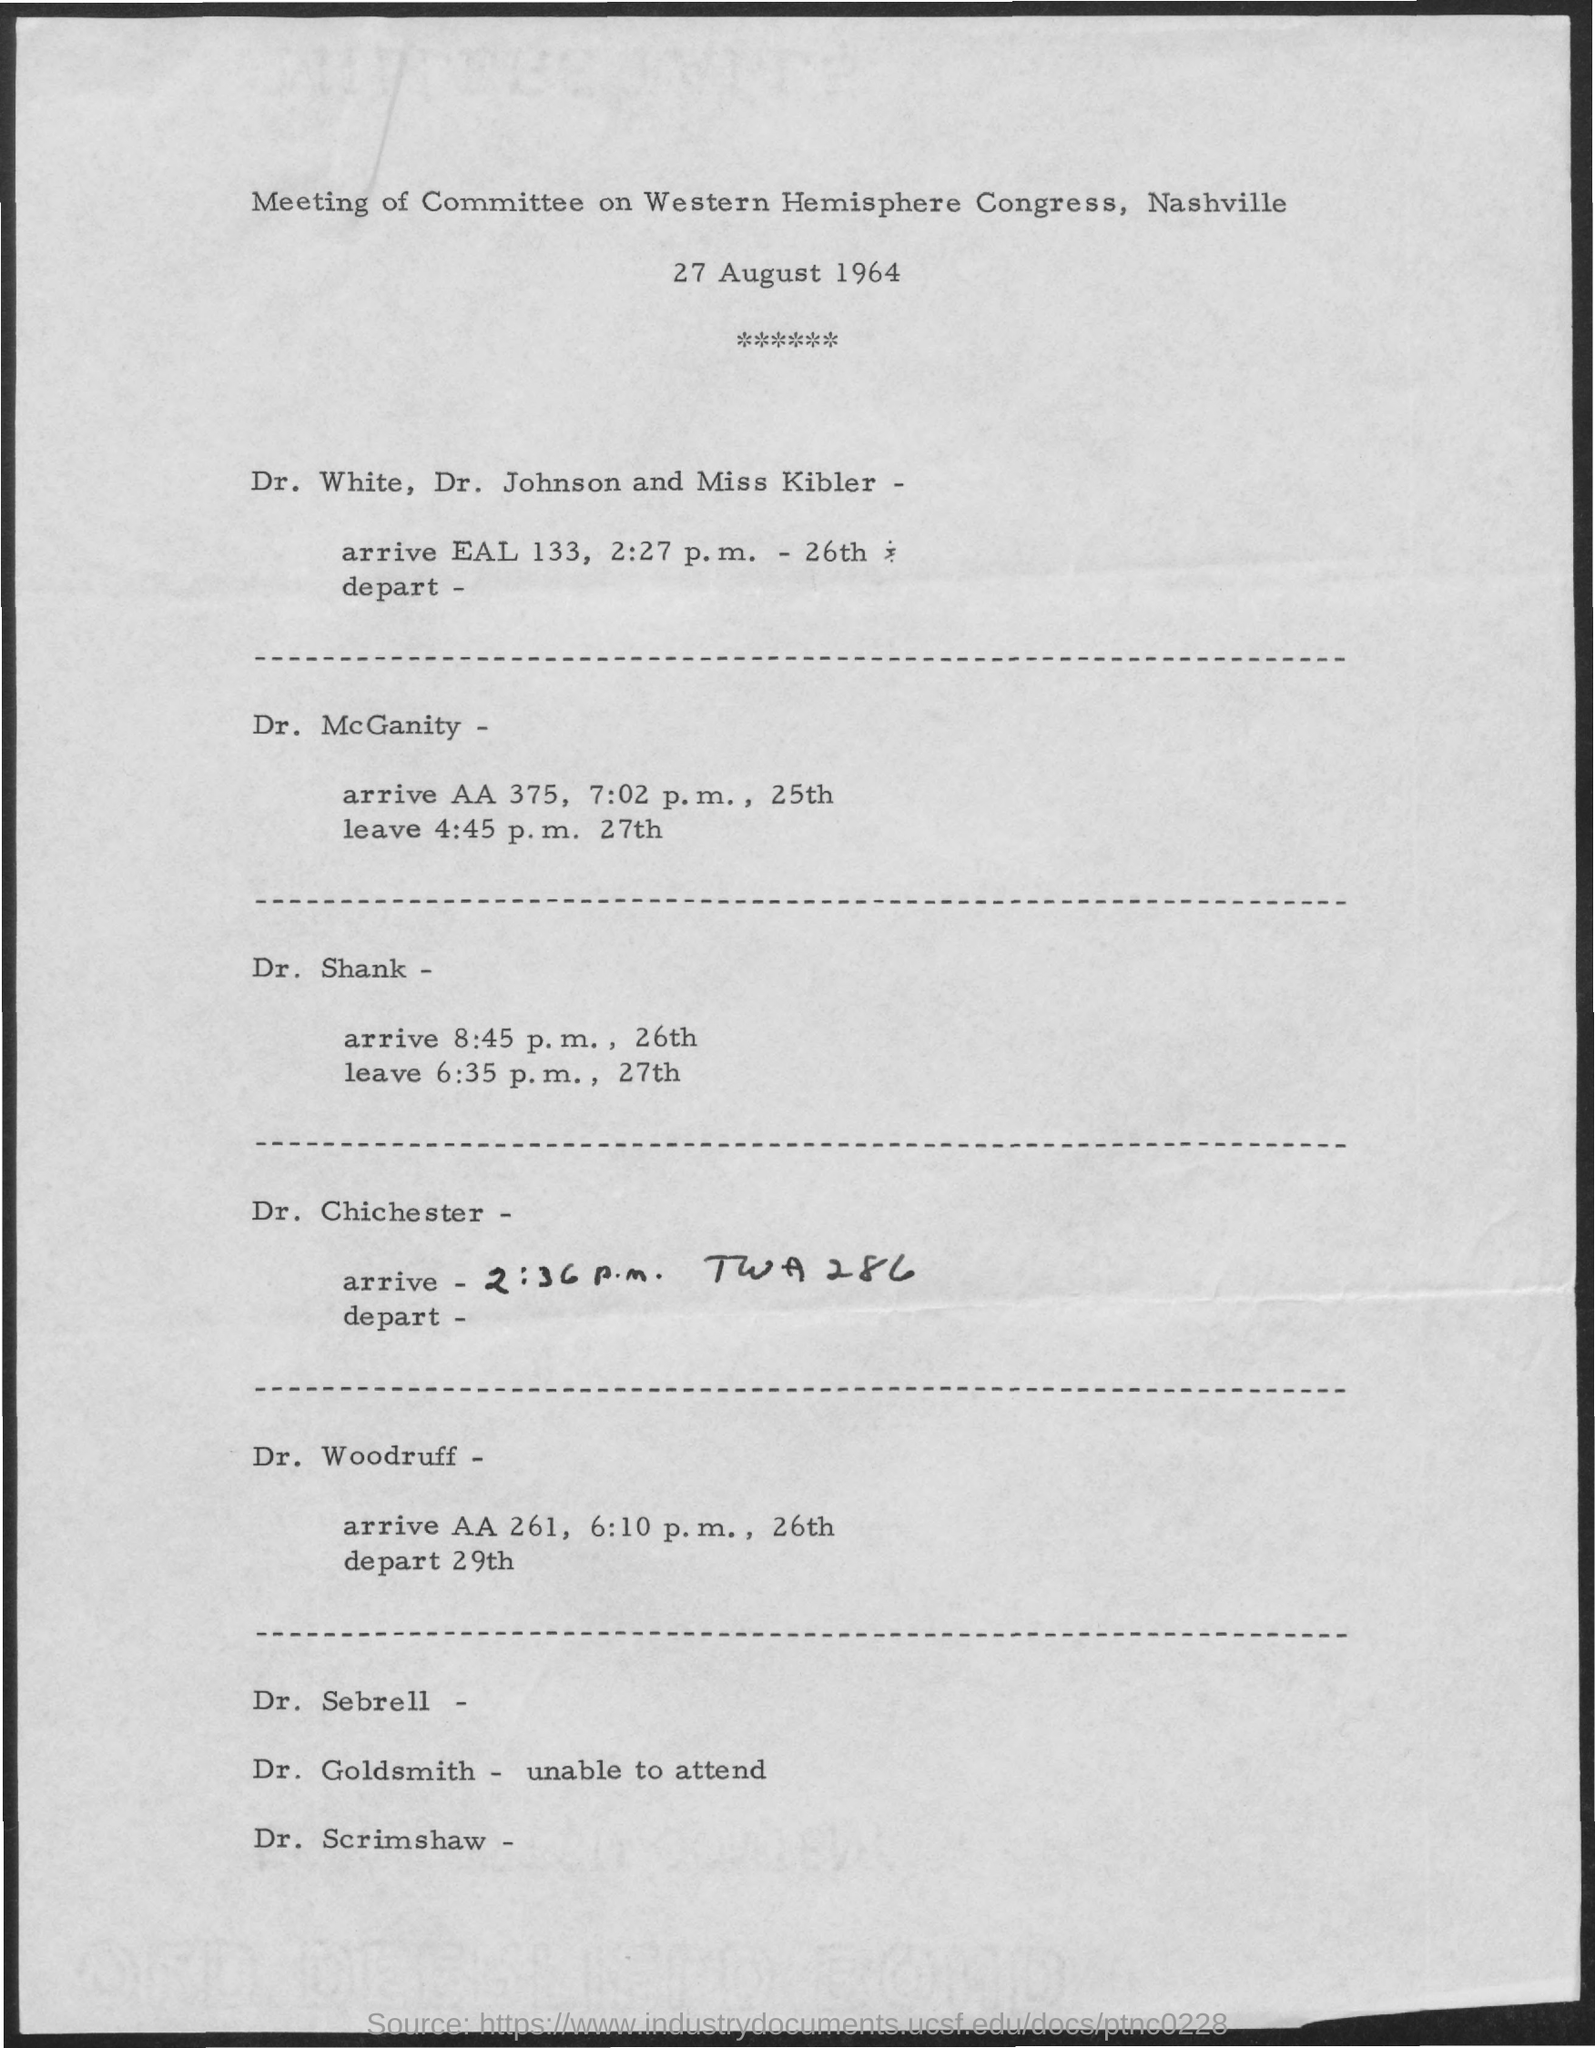Specify some key components in this picture. The meeting of the Committee on Western Hemisphere Congress, held on August 27, 1964, in Nashville, was a successful event. 